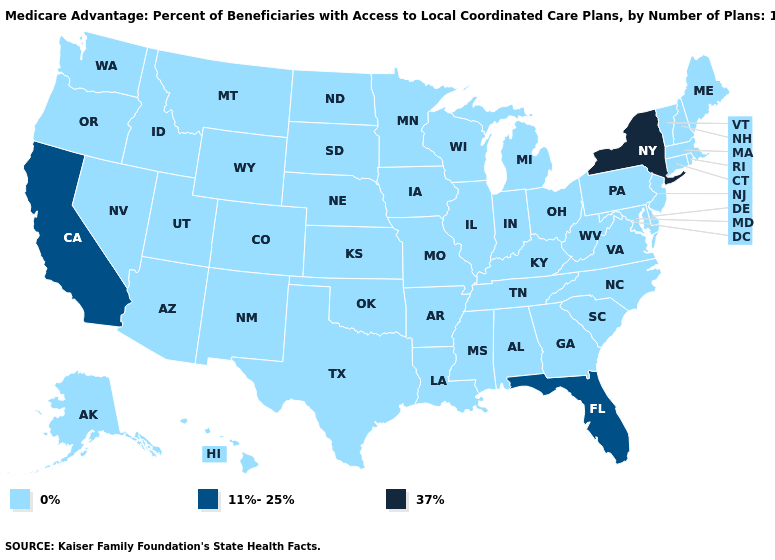What is the highest value in the USA?
Answer briefly. 37%. What is the value of Alaska?
Short answer required. 0%. Does the map have missing data?
Give a very brief answer. No. Among the states that border Maine , which have the lowest value?
Concise answer only. New Hampshire. How many symbols are there in the legend?
Quick response, please. 3. What is the value of Delaware?
Quick response, please. 0%. Which states have the highest value in the USA?
Be succinct. New York. What is the highest value in states that border Louisiana?
Quick response, please. 0%. Does South Carolina have the lowest value in the USA?
Short answer required. Yes. How many symbols are there in the legend?
Write a very short answer. 3. Does Tennessee have the highest value in the South?
Quick response, please. No. Among the states that border Virginia , which have the lowest value?
Quick response, please. Kentucky, Maryland, North Carolina, Tennessee, West Virginia. Name the states that have a value in the range 11%-25%?
Be succinct. California, Florida. What is the value of South Carolina?
Keep it brief. 0%. Name the states that have a value in the range 37%?
Be succinct. New York. 